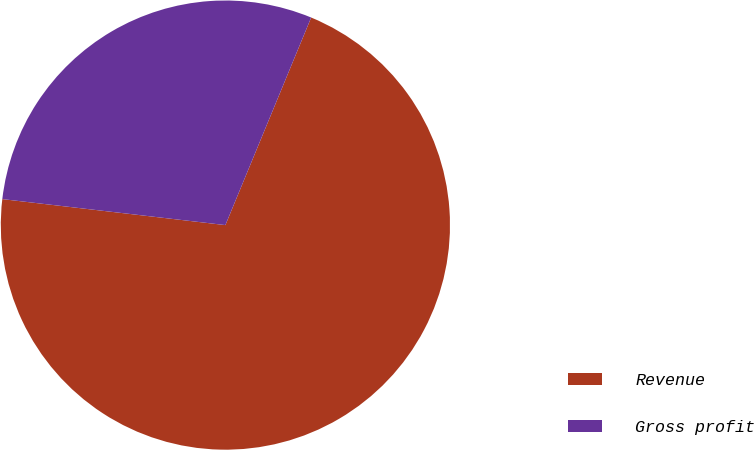<chart> <loc_0><loc_0><loc_500><loc_500><pie_chart><fcel>Revenue<fcel>Gross profit<nl><fcel>70.61%<fcel>29.39%<nl></chart> 